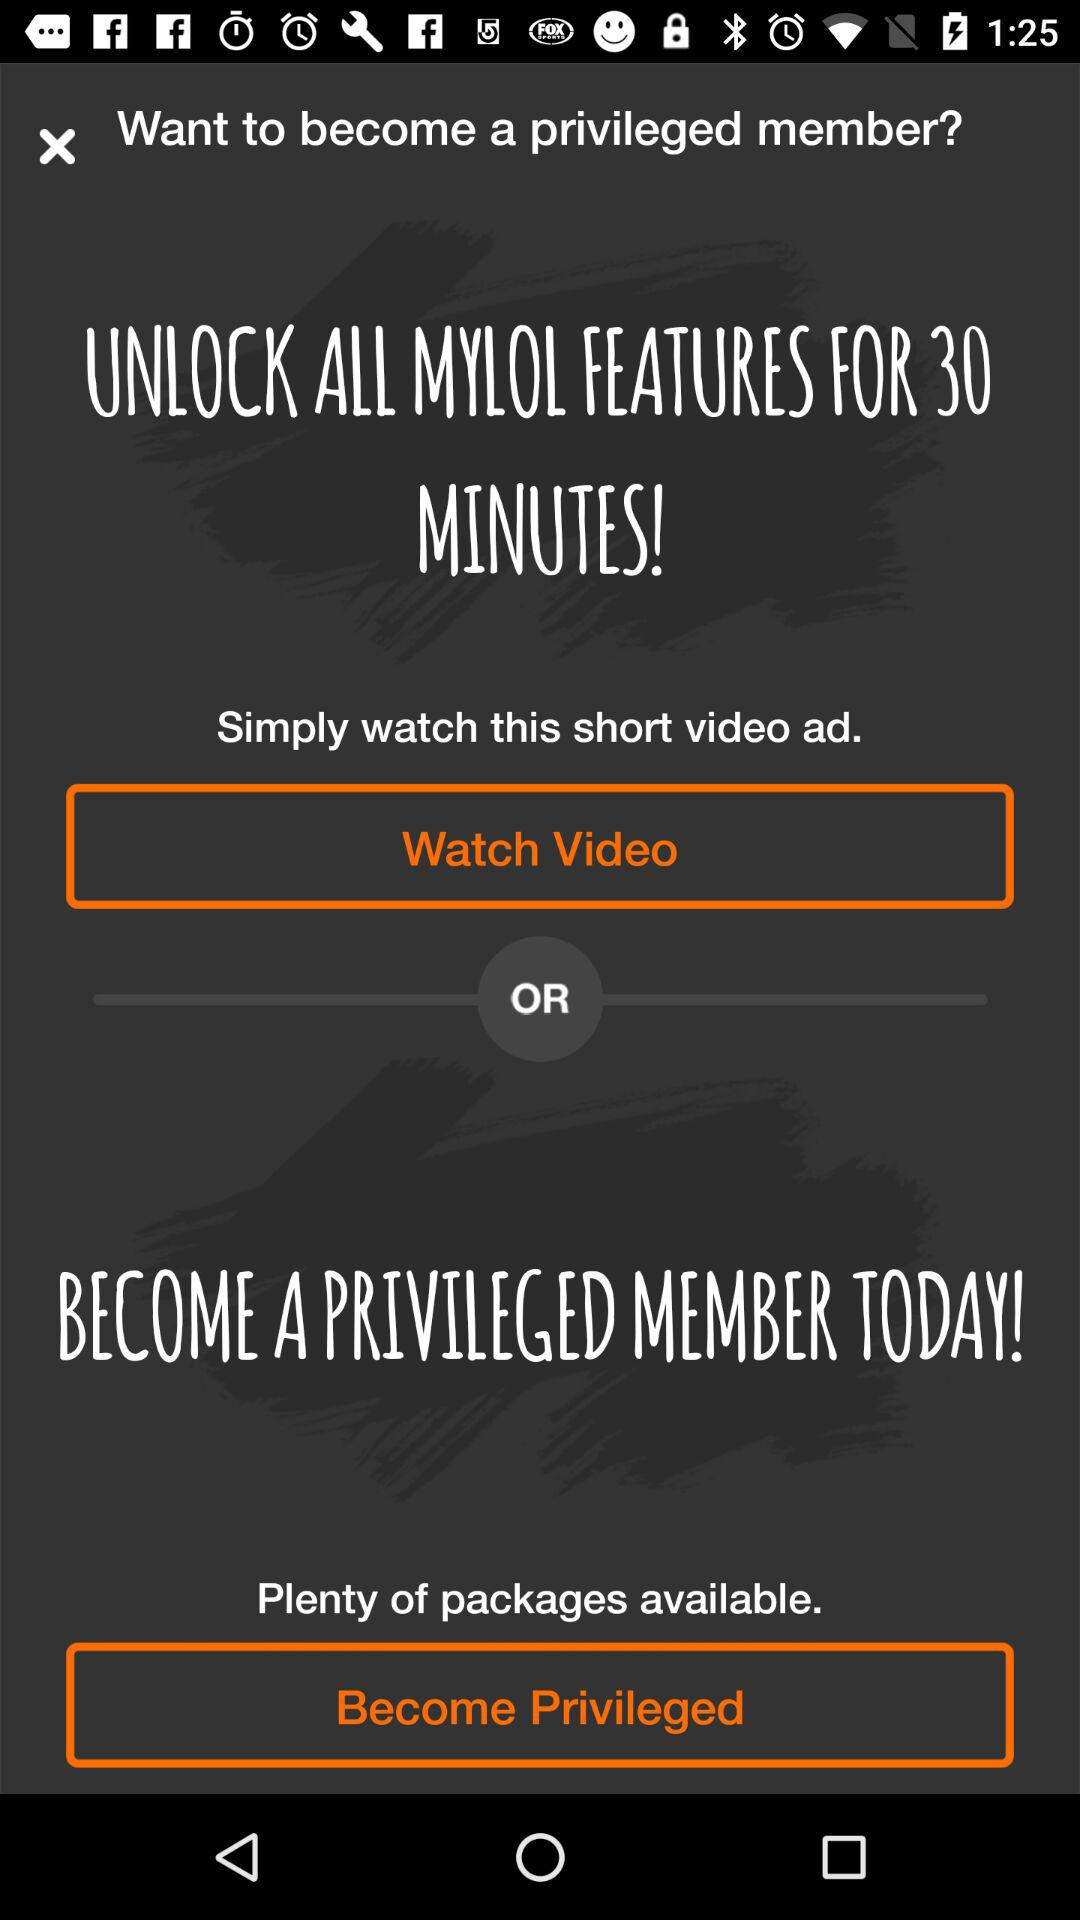For how many minutes can all features be unlocked? All features can be unlocked for 30 minutes. 